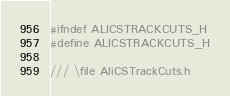Convert code to text. <code><loc_0><loc_0><loc_500><loc_500><_C_>#ifndef ALICSTRACKCUTS_H
#define ALICSTRACKCUTS_H

/// \file AliCSTrackCuts.h</code> 